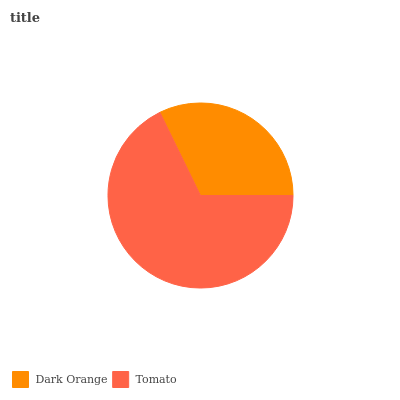Is Dark Orange the minimum?
Answer yes or no. Yes. Is Tomato the maximum?
Answer yes or no. Yes. Is Tomato the minimum?
Answer yes or no. No. Is Tomato greater than Dark Orange?
Answer yes or no. Yes. Is Dark Orange less than Tomato?
Answer yes or no. Yes. Is Dark Orange greater than Tomato?
Answer yes or no. No. Is Tomato less than Dark Orange?
Answer yes or no. No. Is Tomato the high median?
Answer yes or no. Yes. Is Dark Orange the low median?
Answer yes or no. Yes. Is Dark Orange the high median?
Answer yes or no. No. Is Tomato the low median?
Answer yes or no. No. 